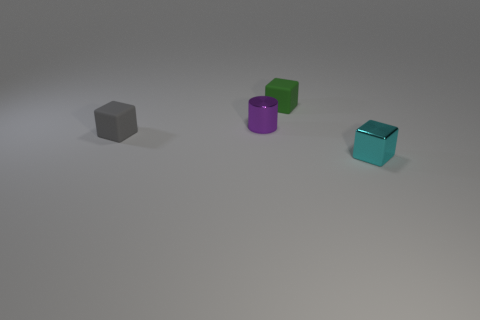How would you describe the arrangement of the objects with respect to each other? The objects are arranged in a staggered formation across the plane with ample space between each other, offering a sense of organized randomness. This layout allows each object to be seen individually, highlighting their distinct colors and shapes. 